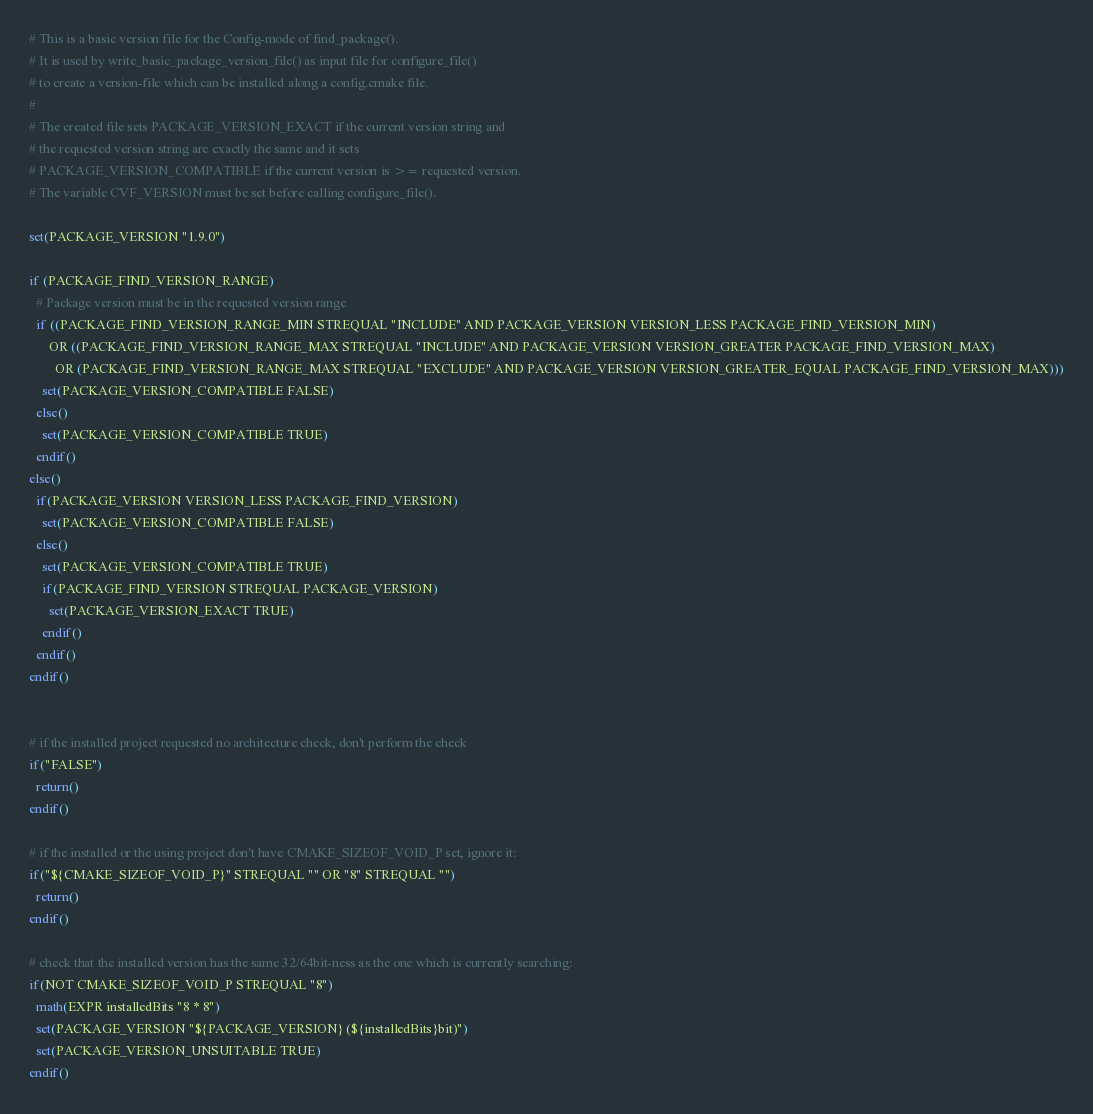Convert code to text. <code><loc_0><loc_0><loc_500><loc_500><_CMake_># This is a basic version file for the Config-mode of find_package().
# It is used by write_basic_package_version_file() as input file for configure_file()
# to create a version-file which can be installed along a config.cmake file.
#
# The created file sets PACKAGE_VERSION_EXACT if the current version string and
# the requested version string are exactly the same and it sets
# PACKAGE_VERSION_COMPATIBLE if the current version is >= requested version.
# The variable CVF_VERSION must be set before calling configure_file().

set(PACKAGE_VERSION "1.9.0")

if (PACKAGE_FIND_VERSION_RANGE)
  # Package version must be in the requested version range
  if ((PACKAGE_FIND_VERSION_RANGE_MIN STREQUAL "INCLUDE" AND PACKAGE_VERSION VERSION_LESS PACKAGE_FIND_VERSION_MIN)
      OR ((PACKAGE_FIND_VERSION_RANGE_MAX STREQUAL "INCLUDE" AND PACKAGE_VERSION VERSION_GREATER PACKAGE_FIND_VERSION_MAX)
        OR (PACKAGE_FIND_VERSION_RANGE_MAX STREQUAL "EXCLUDE" AND PACKAGE_VERSION VERSION_GREATER_EQUAL PACKAGE_FIND_VERSION_MAX)))
    set(PACKAGE_VERSION_COMPATIBLE FALSE)
  else()
    set(PACKAGE_VERSION_COMPATIBLE TRUE)
  endif()
else()
  if(PACKAGE_VERSION VERSION_LESS PACKAGE_FIND_VERSION)
    set(PACKAGE_VERSION_COMPATIBLE FALSE)
  else()
    set(PACKAGE_VERSION_COMPATIBLE TRUE)
    if(PACKAGE_FIND_VERSION STREQUAL PACKAGE_VERSION)
      set(PACKAGE_VERSION_EXACT TRUE)
    endif()
  endif()
endif()


# if the installed project requested no architecture check, don't perform the check
if("FALSE")
  return()
endif()

# if the installed or the using project don't have CMAKE_SIZEOF_VOID_P set, ignore it:
if("${CMAKE_SIZEOF_VOID_P}" STREQUAL "" OR "8" STREQUAL "")
  return()
endif()

# check that the installed version has the same 32/64bit-ness as the one which is currently searching:
if(NOT CMAKE_SIZEOF_VOID_P STREQUAL "8")
  math(EXPR installedBits "8 * 8")
  set(PACKAGE_VERSION "${PACKAGE_VERSION} (${installedBits}bit)")
  set(PACKAGE_VERSION_UNSUITABLE TRUE)
endif()
</code> 